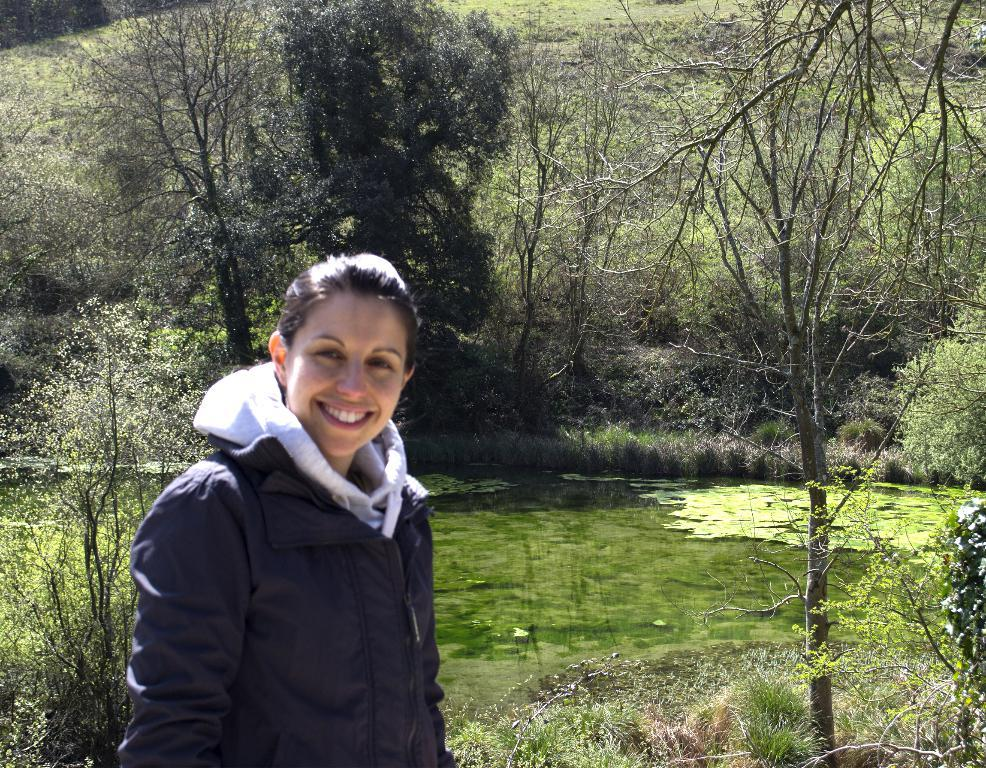Who is present in the image? There is a woman in the image. What is the woman doing in the image? The woman is standing in the image. What is the woman's facial expression in the image? The woman is smiling in the image. What type of natural environment is visible in the image? Grass, water, and trees are visible in the image. What is present in the water in the image? Algae is present in the water in the image. What type of stone is the woman holding in the image? There is no stone present in the image; the woman is not holding anything. What color are the trousers the woman is wearing in the image? The facts provided do not mention the woman's clothing, so we cannot determine the color of her trousers. 